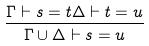Convert formula to latex. <formula><loc_0><loc_0><loc_500><loc_500>\frac { \Gamma \vdash s = t \Delta \vdash t = u } { \Gamma \cup \Delta \vdash s = u }</formula> 